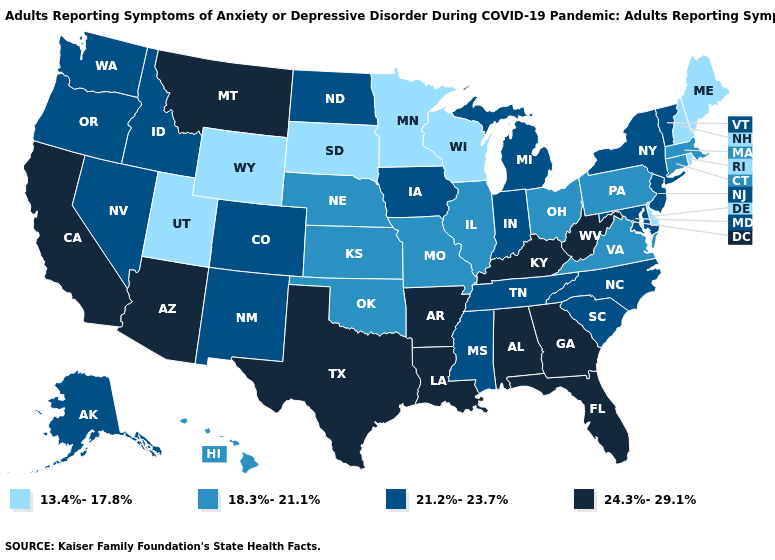Does Wisconsin have the lowest value in the USA?
Quick response, please. Yes. Among the states that border New Mexico , does Arizona have the highest value?
Answer briefly. Yes. Among the states that border Utah , which have the lowest value?
Quick response, please. Wyoming. Among the states that border Kansas , does Missouri have the highest value?
Short answer required. No. Does Arizona have the highest value in the West?
Quick response, please. Yes. Name the states that have a value in the range 18.3%-21.1%?
Quick response, please. Connecticut, Hawaii, Illinois, Kansas, Massachusetts, Missouri, Nebraska, Ohio, Oklahoma, Pennsylvania, Virginia. What is the highest value in the South ?
Be succinct. 24.3%-29.1%. Among the states that border Illinois , which have the lowest value?
Keep it brief. Wisconsin. What is the highest value in states that border Florida?
Be succinct. 24.3%-29.1%. Name the states that have a value in the range 13.4%-17.8%?
Give a very brief answer. Delaware, Maine, Minnesota, New Hampshire, Rhode Island, South Dakota, Utah, Wisconsin, Wyoming. Among the states that border Missouri , does Kentucky have the highest value?
Keep it brief. Yes. Name the states that have a value in the range 21.2%-23.7%?
Short answer required. Alaska, Colorado, Idaho, Indiana, Iowa, Maryland, Michigan, Mississippi, Nevada, New Jersey, New Mexico, New York, North Carolina, North Dakota, Oregon, South Carolina, Tennessee, Vermont, Washington. Does the map have missing data?
Be succinct. No. Among the states that border Alabama , does Florida have the lowest value?
Concise answer only. No. 